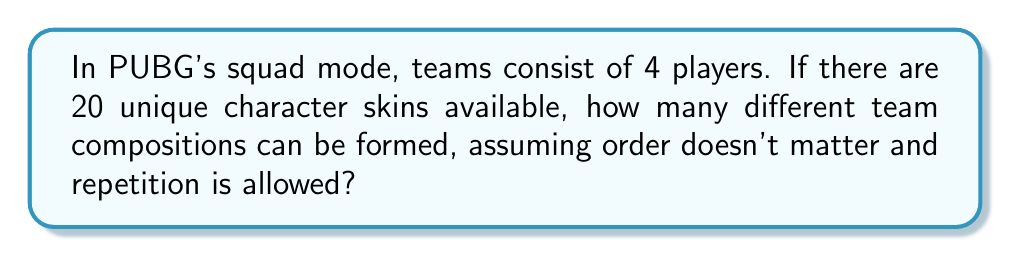Show me your answer to this math problem. Let's approach this step-by-step:

1) This is a combination problem with repetition allowed. We're selecting 4 items (players) from 20 options (character skins), and the order doesn't matter.

2) The formula for combinations with repetition is:

   $$\binom{n+r-1}{r} = \frac{(n+r-1)!}{r!(n-1)!}$$

   Where $n$ is the number of options to choose from, and $r$ is the number of items being chosen.

3) In this case, $n = 20$ (character skins) and $r = 4$ (players in a squad).

4) Plugging these values into our formula:

   $$\binom{20+4-1}{4} = \binom{23}{4} = \frac{23!}{4!(23-4)!} = \frac{23!}{4!19!}$$

5) Calculating this:
   
   $$\frac{23 * 22 * 21 * 20}{4 * 3 * 2 * 1} = 8855$$

Therefore, there are 8855 unique team compositions possible.
Answer: 8855 